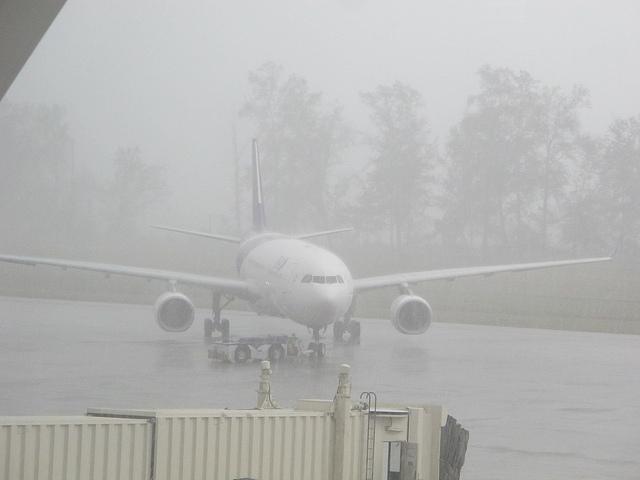Do you see any trees?
Short answer required. Yes. Is the plane moving?
Quick response, please. No. What type of vehicle is in this picture?
Short answer required. Plane. Is it a clear day?
Concise answer only. No. 